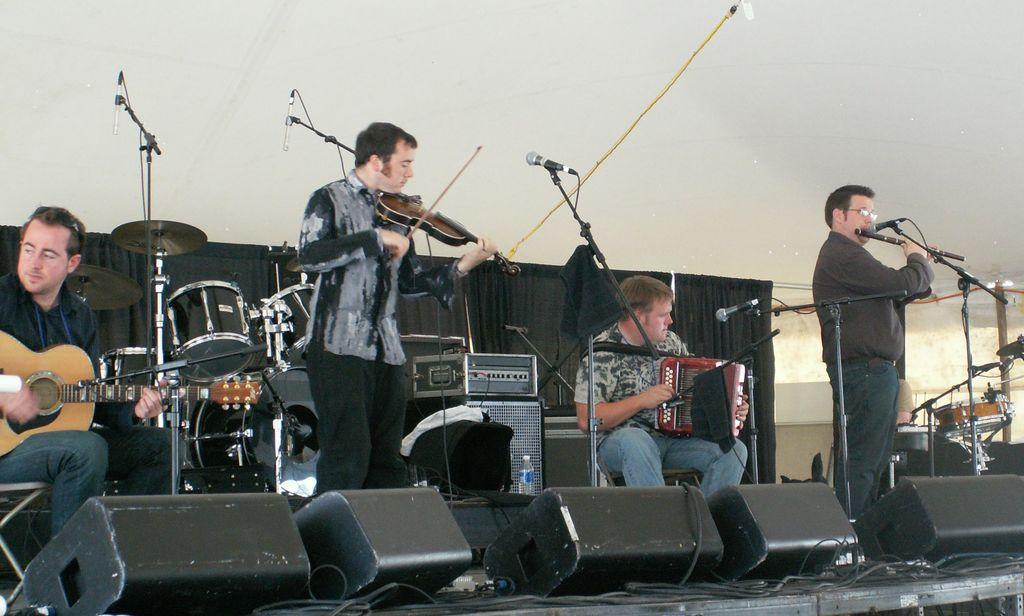Could you give a brief overview of what you see in this image? In this picture there are four persons, one of them is playing flute and another one is playing the violin and the person sitting at the left is playing the guitar and the drum set behind them 